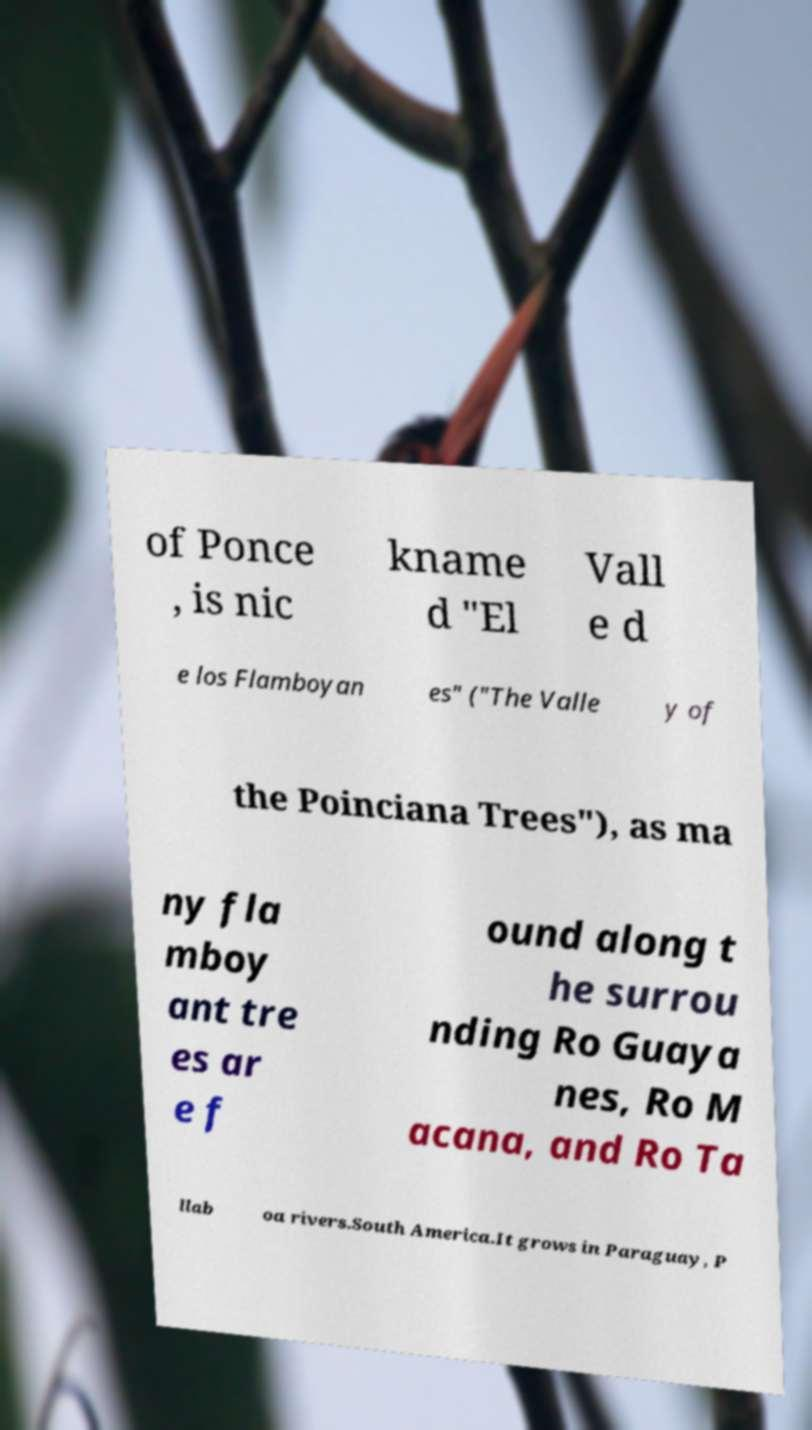Please read and relay the text visible in this image. What does it say? of Ponce , is nic kname d "El Vall e d e los Flamboyan es" ("The Valle y of the Poinciana Trees"), as ma ny fla mboy ant tre es ar e f ound along t he surrou nding Ro Guaya nes, Ro M acana, and Ro Ta llab oa rivers.South America.It grows in Paraguay, P 